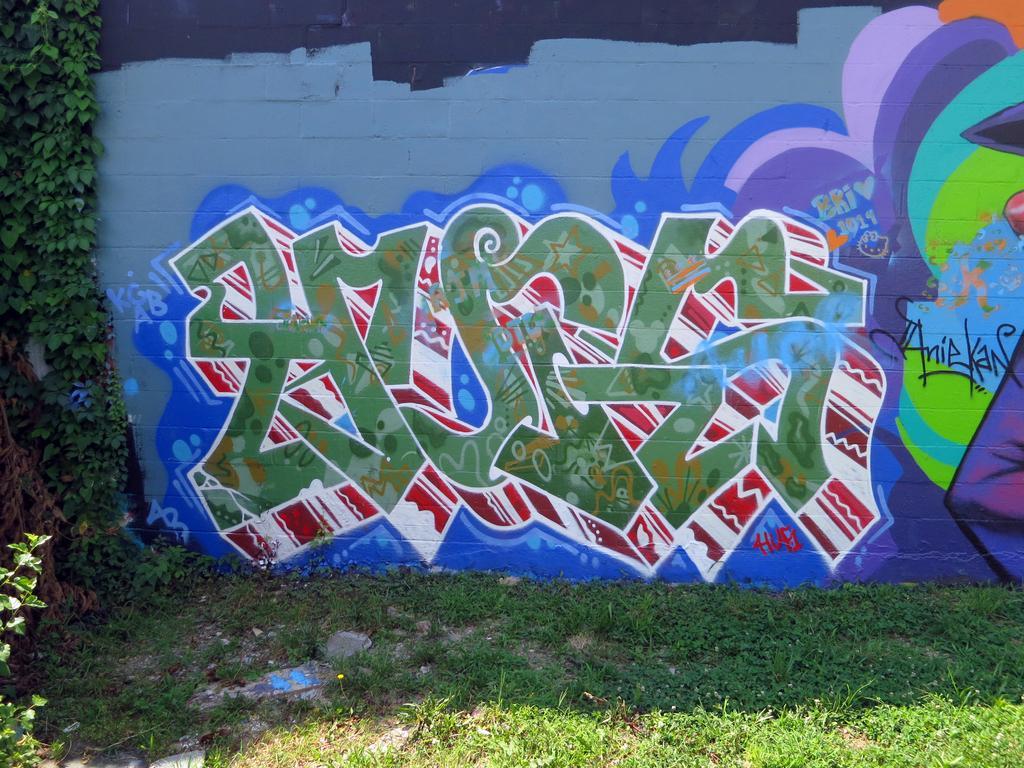Describe this image in one or two sentences. Here we can see graffiti on a wall. On the left we can see plants. At the bottom we can see grass and small stones on the ground. 